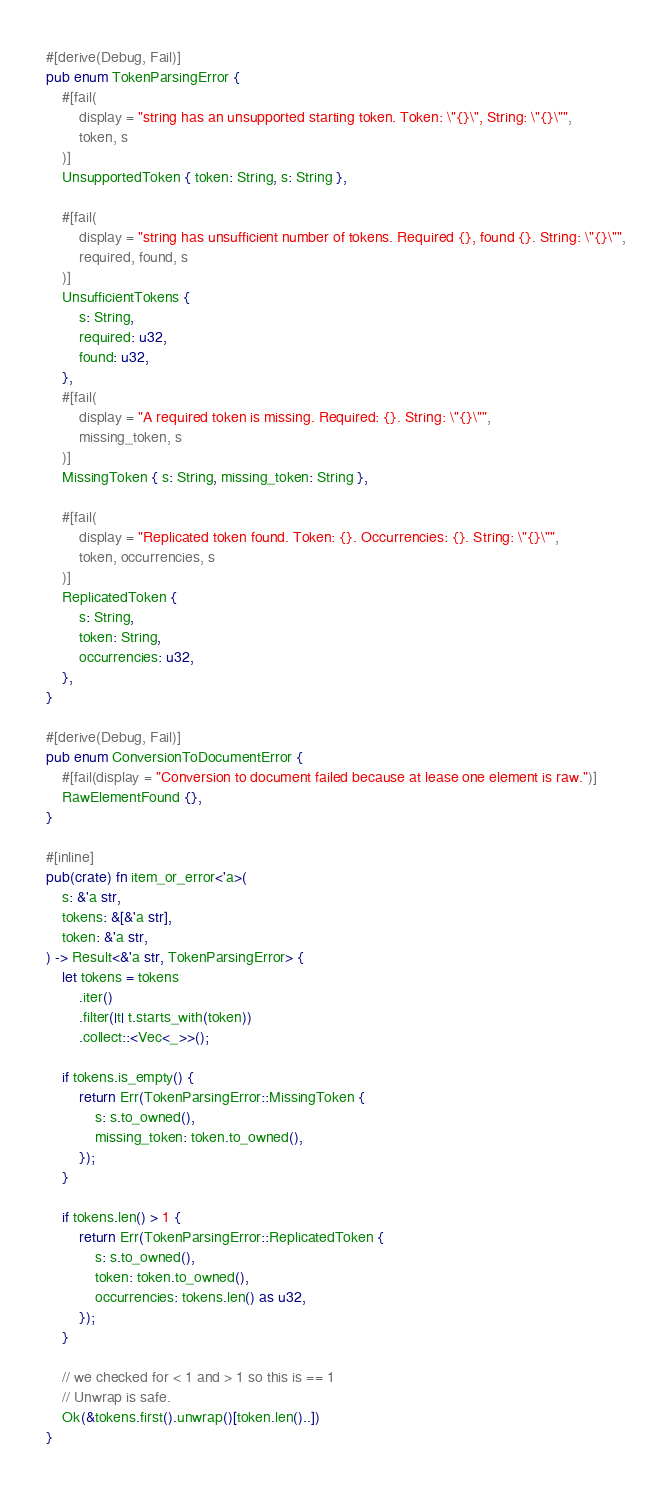<code> <loc_0><loc_0><loc_500><loc_500><_Rust_>#[derive(Debug, Fail)]
pub enum TokenParsingError {
    #[fail(
        display = "string has an unsupported starting token. Token: \"{}\", String: \"{}\"",
        token, s
    )]
    UnsupportedToken { token: String, s: String },

    #[fail(
        display = "string has unsufficient number of tokens. Required {}, found {}. String: \"{}\"",
        required, found, s
    )]
    UnsufficientTokens {
        s: String,
        required: u32,
        found: u32,
    },
    #[fail(
        display = "A required token is missing. Required: {}. String: \"{}\"",
        missing_token, s
    )]
    MissingToken { s: String, missing_token: String },

    #[fail(
        display = "Replicated token found. Token: {}. Occurrencies: {}. String: \"{}\"",
        token, occurrencies, s
    )]
    ReplicatedToken {
        s: String,
        token: String,
        occurrencies: u32,
    },
}

#[derive(Debug, Fail)]
pub enum ConversionToDocumentError {
    #[fail(display = "Conversion to document failed because at lease one element is raw.")]
    RawElementFound {},
}

#[inline]
pub(crate) fn item_or_error<'a>(
    s: &'a str,
    tokens: &[&'a str],
    token: &'a str,
) -> Result<&'a str, TokenParsingError> {
    let tokens = tokens
        .iter()
        .filter(|t| t.starts_with(token))
        .collect::<Vec<_>>();

    if tokens.is_empty() {
        return Err(TokenParsingError::MissingToken {
            s: s.to_owned(),
            missing_token: token.to_owned(),
        });
    }

    if tokens.len() > 1 {
        return Err(TokenParsingError::ReplicatedToken {
            s: s.to_owned(),
            token: token.to_owned(),
            occurrencies: tokens.len() as u32,
        });
    }

    // we checked for < 1 and > 1 so this is == 1
    // Unwrap is safe.
    Ok(&tokens.first().unwrap()[token.len()..])
}
</code> 